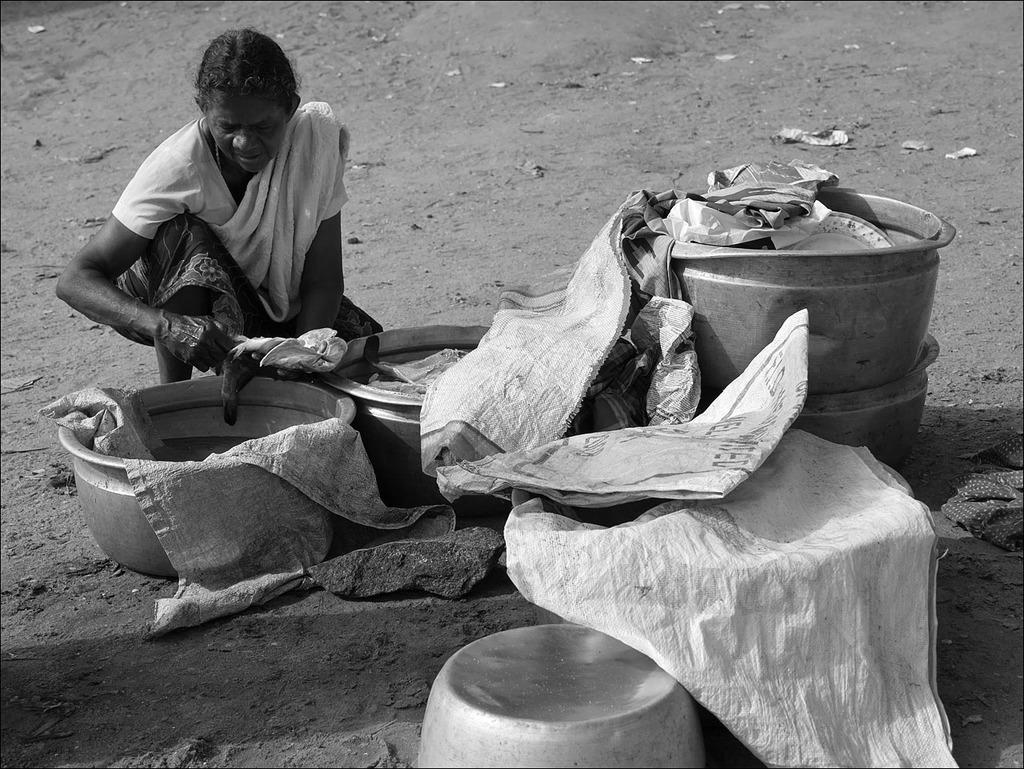What is the color scheme of the image? The image is black and white. What is the woman in the image doing? The woman is sitting on the ground. What objects are in front of the woman? There are dishes in front of the woman. How are the dishes covered? The dishes are covered with a bag. What type of horn can be seen in the image? There is no horn present in the image. What shape is the dirt in the image? There is no dirt present in the image. 